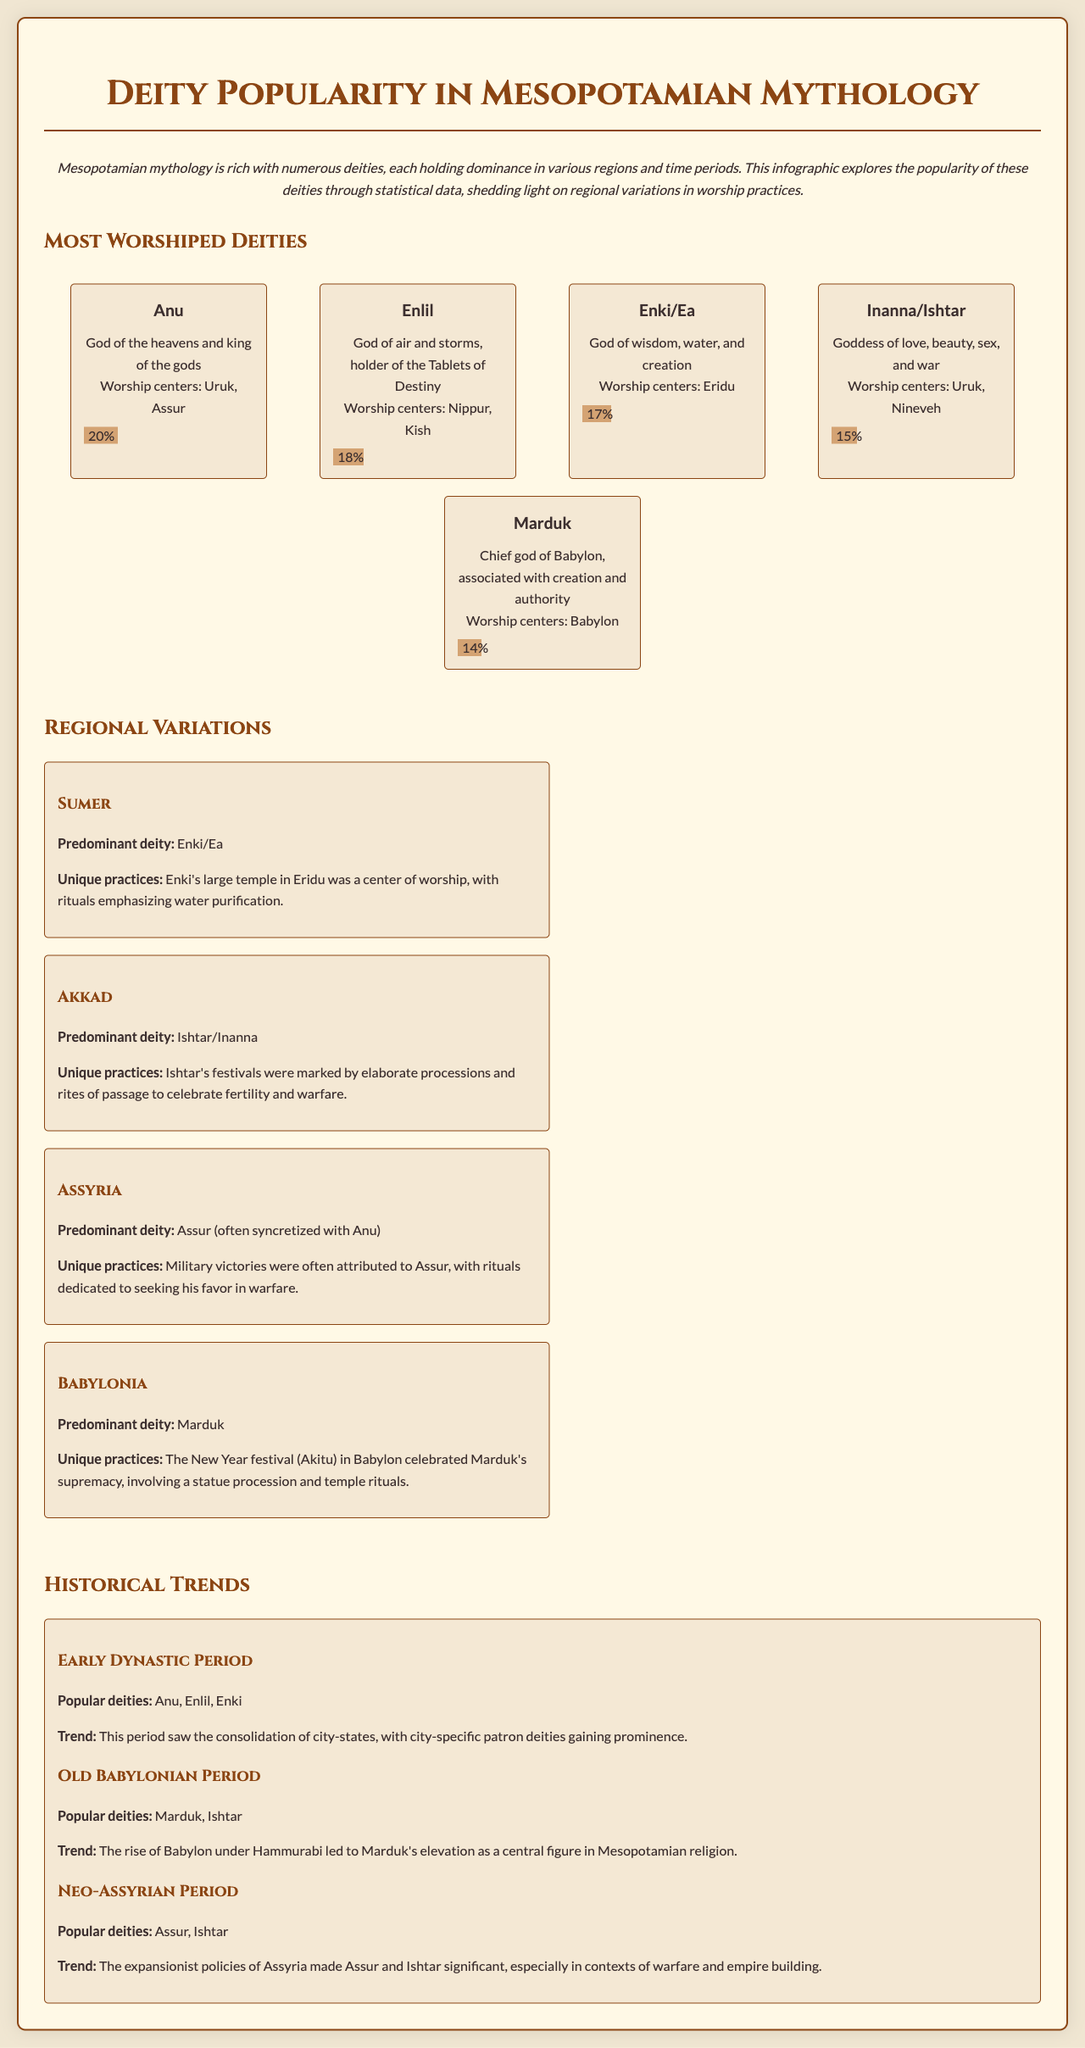What are the two most worshiped deities? The two most worshiped deities are Anu and Enlil, as they appear at the top of the infographic with the highest percentages.
Answer: Anu, Enlil What percentage of worship does Enki/Ea have? Enki/Ea's worship percentage is represented on the popularity bar, which shows 17%.
Answer: 17% Which deity is predominantly worshiped in Sumer? The infographic specifies that the predominant deity in Sumer is Enki/Ea, as highlighted in the regional variations section.
Answer: Enki/Ea What unique practice is associated with Ishtar in the Akkad region? The document states that Ishtar's festivals involved elaborate processions and rites of passage.
Answer: Elaborate processions In which historical period did Marduk rise to prominence? The Old Babylonian Period is noted for Marduk's elevation as a central figure in Mesopotamian religion.
Answer: Old Babylonian Period Which god is associated with military victories in Assyria? The region section details that Assur (often syncretized with Anu) is the deity associated with military victories.
Answer: Assur What is the significance of the Akitu festival in Babylon? The infographic explains that the Akitu festival celebrates Marduk's supremacy, with temple rituals and statue processions.
Answer: Celebration of Marduk's supremacy What deity is associated with the New Year festival in Babylonia? Marduk is mentioned as the chief god celebrated during the New Year festival in Babylon, according to the regional variations.
Answer: Marduk 